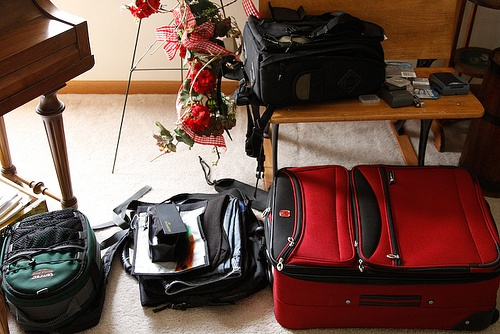Describe the objects in this image and their specific colors. I can see suitcase in black, maroon, and brown tones, backpack in black, gray, white, and darkgray tones, bench in black, maroon, and brown tones, backpack in black, gray, teal, and darkgray tones, and suitcase in black, gray, and maroon tones in this image. 